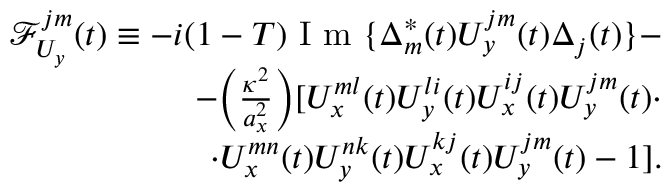Convert formula to latex. <formula><loc_0><loc_0><loc_500><loc_500>\begin{array} { r } { \mathcal { F } _ { U _ { y } } ^ { j m } ( t ) \equiv - i ( 1 - T ) I m \{ \Delta _ { m } ^ { * } ( t ) U _ { y } ^ { j m } ( t ) \Delta _ { j } ( t ) \} - } \\ { - \left ( \frac { \kappa ^ { 2 } } { a _ { x } ^ { 2 } } \right ) [ U _ { x } ^ { m l } ( t ) U _ { y } ^ { l i } ( t ) U _ { x } ^ { i j } ( t ) U _ { y } ^ { j m } ( t ) \cdot } \\ { \cdot U _ { x } ^ { m n } ( t ) U _ { y } ^ { n k } ( t ) U _ { x } ^ { k j } ( t ) U _ { y } ^ { j m } ( t ) - 1 ] . } \end{array}</formula> 